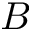<formula> <loc_0><loc_0><loc_500><loc_500>B</formula> 